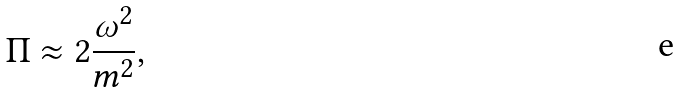<formula> <loc_0><loc_0><loc_500><loc_500>\Pi \approx 2 \frac { \omega ^ { 2 } } { m ^ { 2 } } ,</formula> 